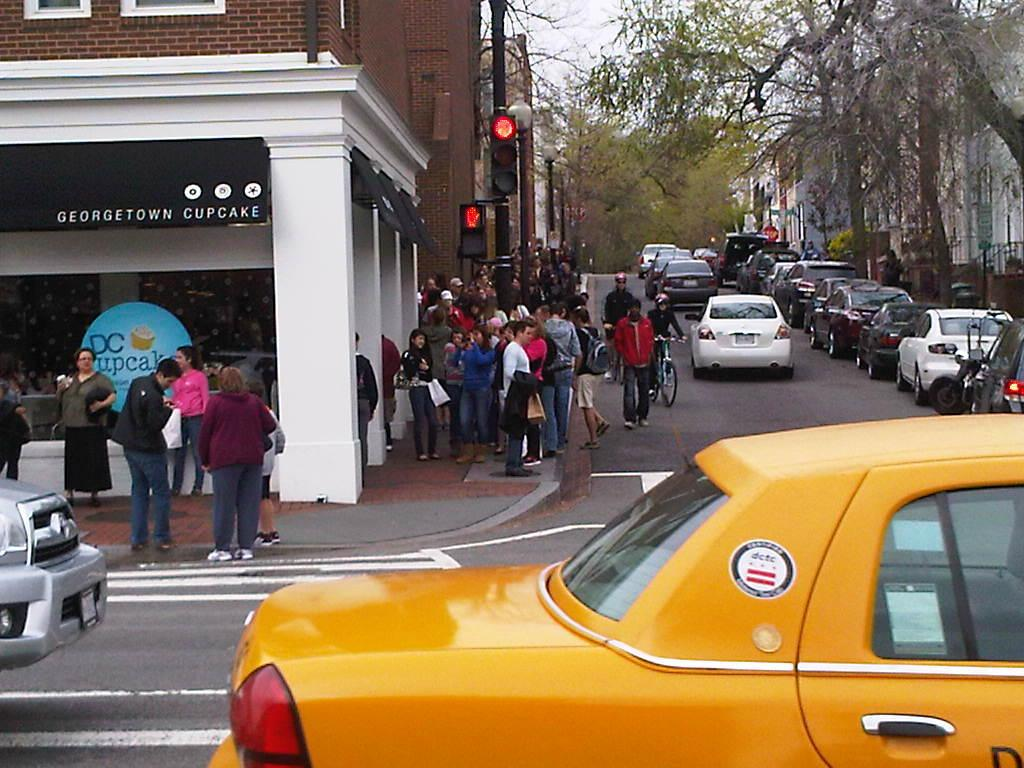<image>
Offer a succinct explanation of the picture presented. A group of people are standing outside of a cupcake store. 